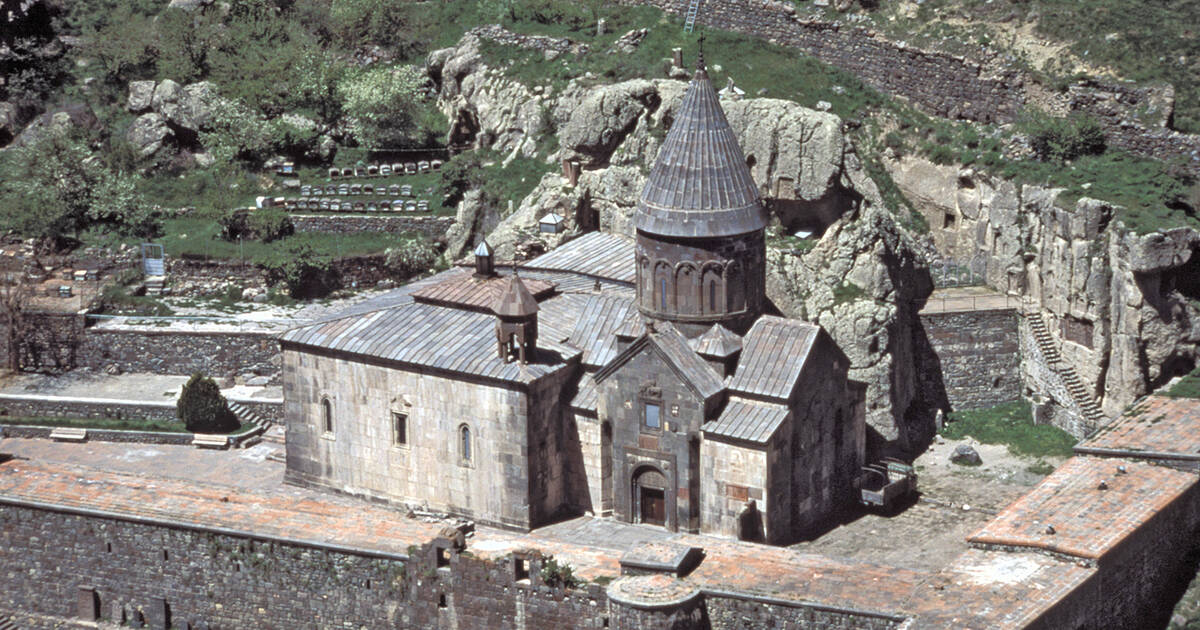What details can be observed about the stone carving techniques used in the monastery? The stone carving techniques evident in the monastery showcase fine craftsmanship typical of medieval Armenian architecture. The technique involves precise chiseling to create detailed religious motifs and khachkars on the basalt surface, which is known for its durability and adaptability to detailed work. Observing the facades, you can see intricate designs that likely served both decorative and religious purposes, illustrating biblical scenes and crosses that symbolize deep spiritual reverence. 